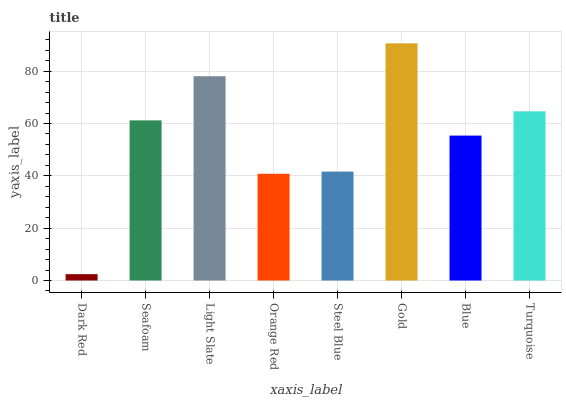Is Dark Red the minimum?
Answer yes or no. Yes. Is Gold the maximum?
Answer yes or no. Yes. Is Seafoam the minimum?
Answer yes or no. No. Is Seafoam the maximum?
Answer yes or no. No. Is Seafoam greater than Dark Red?
Answer yes or no. Yes. Is Dark Red less than Seafoam?
Answer yes or no. Yes. Is Dark Red greater than Seafoam?
Answer yes or no. No. Is Seafoam less than Dark Red?
Answer yes or no. No. Is Seafoam the high median?
Answer yes or no. Yes. Is Blue the low median?
Answer yes or no. Yes. Is Blue the high median?
Answer yes or no. No. Is Steel Blue the low median?
Answer yes or no. No. 